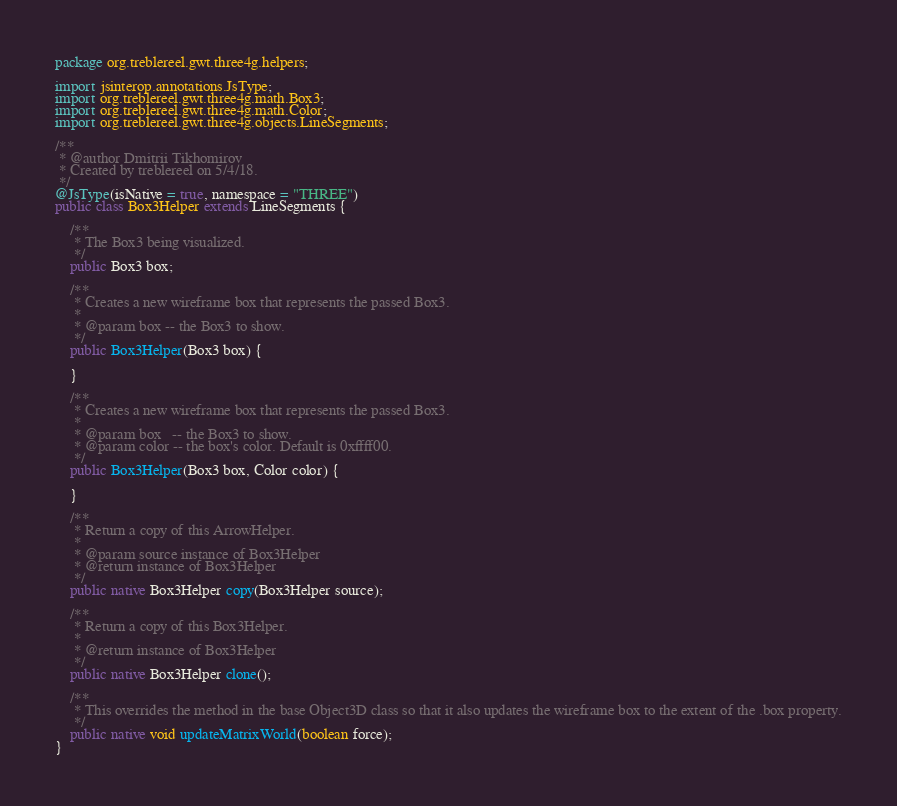<code> <loc_0><loc_0><loc_500><loc_500><_Java_>package org.treblereel.gwt.three4g.helpers;

import jsinterop.annotations.JsType;
import org.treblereel.gwt.three4g.math.Box3;
import org.treblereel.gwt.three4g.math.Color;
import org.treblereel.gwt.three4g.objects.LineSegments;

/**
 * @author Dmitrii Tikhomirov
 * Created by treblereel on 5/4/18.
 */
@JsType(isNative = true, namespace = "THREE")
public class Box3Helper extends LineSegments {

    /**
     * The Box3 being visualized.
     */
    public Box3 box;

    /**
     * Creates a new wireframe box that represents the passed Box3.
     *
     * @param box -- the Box3 to show.
     */
    public Box3Helper(Box3 box) {

    }

    /**
     * Creates a new wireframe box that represents the passed Box3.
     *
     * @param box   -- the Box3 to show.
     * @param color -- the box's color. Default is 0xffff00.
     */
    public Box3Helper(Box3 box, Color color) {

    }

    /**
     * Return a copy of this ArrowHelper.
     *
     * @param source instance of Box3Helper
     * @return instance of Box3Helper
     */
    public native Box3Helper copy(Box3Helper source);

    /**
     * Return a copy of this Box3Helper.
     *
     * @return instance of Box3Helper
     */
    public native Box3Helper clone();

    /**
     * This overrides the method in the base Object3D class so that it also updates the wireframe box to the extent of the .box property.
     */
    public native void updateMatrixWorld(boolean force);
}
</code> 